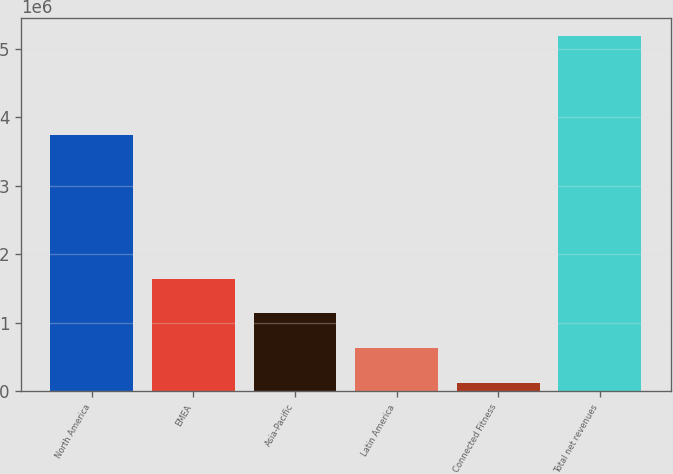<chart> <loc_0><loc_0><loc_500><loc_500><bar_chart><fcel>North America<fcel>EMEA<fcel>Asia-Pacific<fcel>Latin America<fcel>Connected Fitness<fcel>Total net revenues<nl><fcel>3.73529e+06<fcel>1.64221e+06<fcel>1.13492e+06<fcel>627640<fcel>120357<fcel>5.19318e+06<nl></chart> 